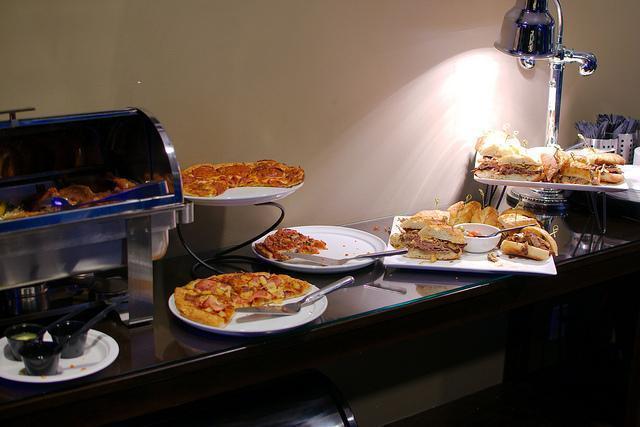What kind of service was this?
From the following four choices, select the correct answer to address the question.
Options: Catering, delivery, home made, restaurant. Catering. 